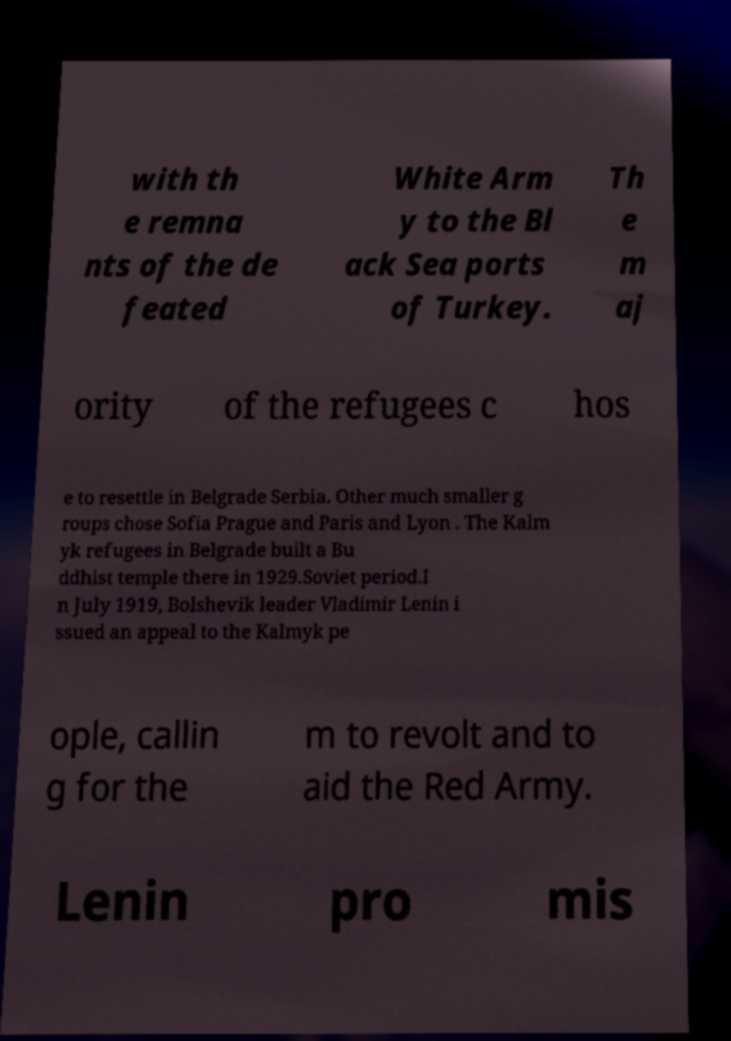There's text embedded in this image that I need extracted. Can you transcribe it verbatim? with th e remna nts of the de feated White Arm y to the Bl ack Sea ports of Turkey. Th e m aj ority of the refugees c hos e to resettle in Belgrade Serbia. Other much smaller g roups chose Sofia Prague and Paris and Lyon . The Kalm yk refugees in Belgrade built a Bu ddhist temple there in 1929.Soviet period.I n July 1919, Bolshevik leader Vladimir Lenin i ssued an appeal to the Kalmyk pe ople, callin g for the m to revolt and to aid the Red Army. Lenin pro mis 